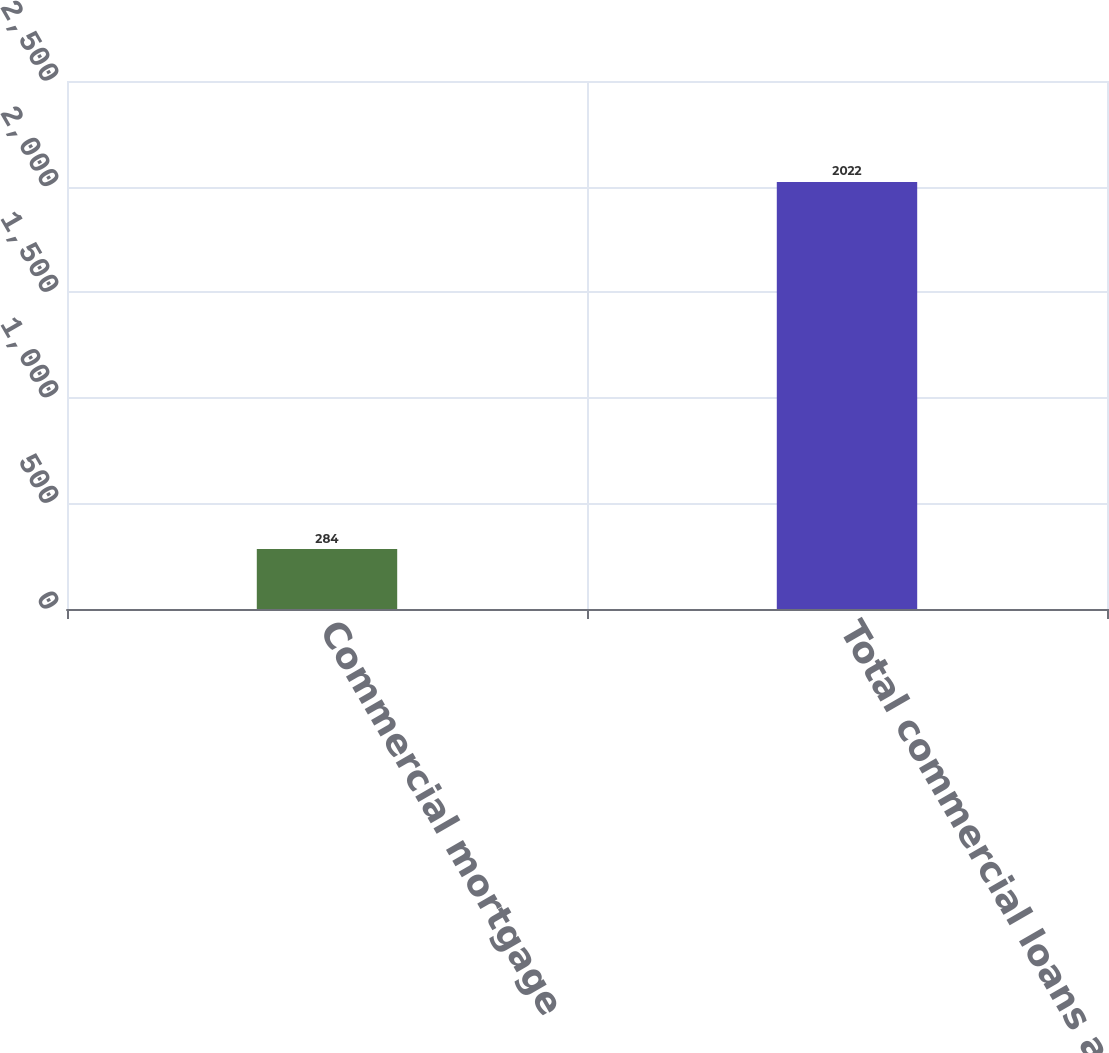Convert chart to OTSL. <chart><loc_0><loc_0><loc_500><loc_500><bar_chart><fcel>Commercial mortgage<fcel>Total commercial loans and<nl><fcel>284<fcel>2022<nl></chart> 